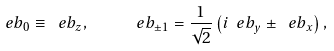Convert formula to latex. <formula><loc_0><loc_0><loc_500><loc_500>\ e b _ { 0 } \equiv \ e b _ { z } , \quad \ e b _ { \pm 1 } = \frac { 1 } { \sqrt { 2 } } \left ( i \ e b _ { y } \pm \ e b _ { x } \right ) ,</formula> 